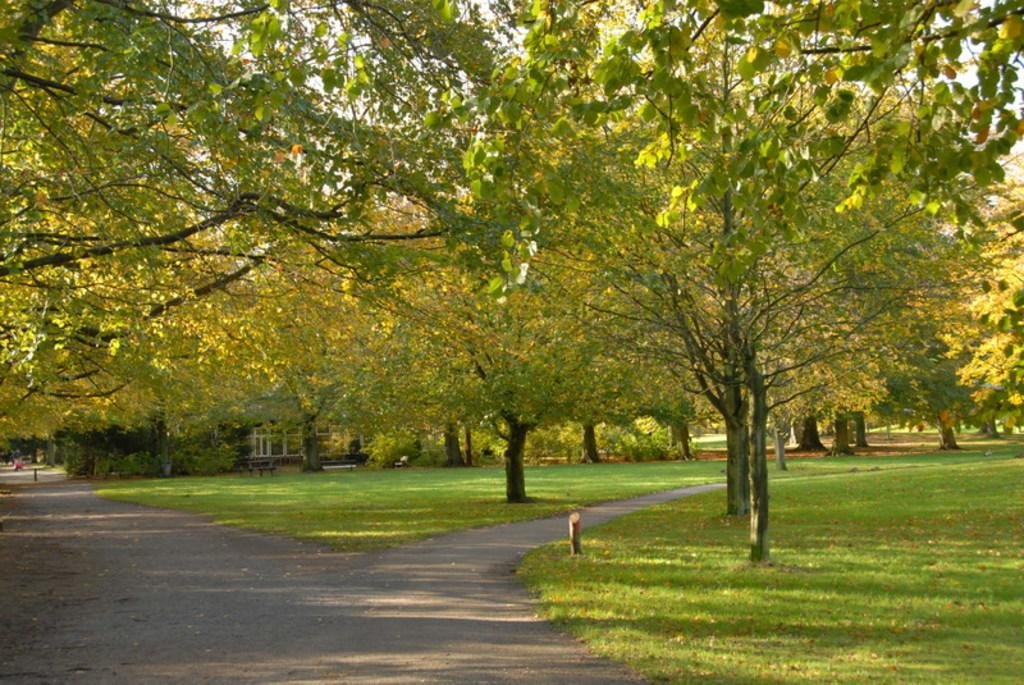What type of vegetation can be seen in the image? There is grass in the image. What other natural elements are present in the image? There are trees in the image. What structure can be seen in the background of the image? There is a house in the background of the image. What type of noise can be heard coming from the trees in the image? There is no indication of any noise in the image, as it is a still picture. What iron objects can be seen in the image? There is no iron object present in the image. 